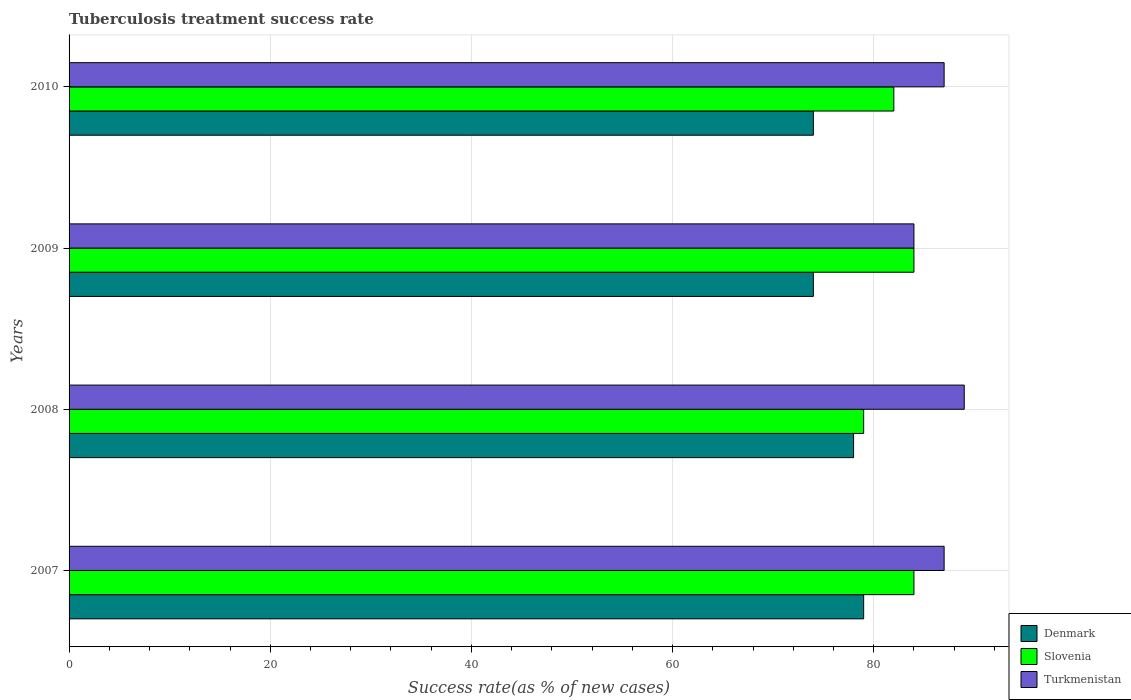Are the number of bars on each tick of the Y-axis equal?
Give a very brief answer. Yes. How many bars are there on the 4th tick from the top?
Offer a very short reply. 3. How many bars are there on the 3rd tick from the bottom?
Offer a terse response. 3. What is the label of the 4th group of bars from the top?
Give a very brief answer. 2007. What is the tuberculosis treatment success rate in Denmark in 2009?
Give a very brief answer. 74. Across all years, what is the maximum tuberculosis treatment success rate in Denmark?
Offer a very short reply. 79. What is the total tuberculosis treatment success rate in Turkmenistan in the graph?
Provide a short and direct response. 347. What is the difference between the tuberculosis treatment success rate in Turkmenistan in 2007 and that in 2010?
Offer a terse response. 0. What is the difference between the tuberculosis treatment success rate in Turkmenistan in 2010 and the tuberculosis treatment success rate in Denmark in 2009?
Provide a short and direct response. 13. What is the average tuberculosis treatment success rate in Denmark per year?
Your response must be concise. 76.25. What is the ratio of the tuberculosis treatment success rate in Slovenia in 2008 to that in 2009?
Give a very brief answer. 0.94. Is the tuberculosis treatment success rate in Slovenia in 2008 less than that in 2010?
Provide a short and direct response. Yes. Is the difference between the tuberculosis treatment success rate in Slovenia in 2007 and 2009 greater than the difference between the tuberculosis treatment success rate in Denmark in 2007 and 2009?
Offer a terse response. No. What is the difference between the highest and the lowest tuberculosis treatment success rate in Denmark?
Keep it short and to the point. 5. In how many years, is the tuberculosis treatment success rate in Denmark greater than the average tuberculosis treatment success rate in Denmark taken over all years?
Your response must be concise. 2. What does the 1st bar from the top in 2008 represents?
Offer a very short reply. Turkmenistan. What does the 3rd bar from the bottom in 2007 represents?
Keep it short and to the point. Turkmenistan. How many bars are there?
Ensure brevity in your answer.  12. What is the difference between two consecutive major ticks on the X-axis?
Offer a terse response. 20. How many legend labels are there?
Keep it short and to the point. 3. What is the title of the graph?
Offer a terse response. Tuberculosis treatment success rate. What is the label or title of the X-axis?
Your response must be concise. Success rate(as % of new cases). What is the label or title of the Y-axis?
Make the answer very short. Years. What is the Success rate(as % of new cases) in Denmark in 2007?
Offer a very short reply. 79. What is the Success rate(as % of new cases) in Turkmenistan in 2007?
Offer a terse response. 87. What is the Success rate(as % of new cases) of Denmark in 2008?
Provide a short and direct response. 78. What is the Success rate(as % of new cases) of Slovenia in 2008?
Ensure brevity in your answer.  79. What is the Success rate(as % of new cases) of Turkmenistan in 2008?
Your answer should be compact. 89. What is the Success rate(as % of new cases) in Slovenia in 2009?
Provide a succinct answer. 84. What is the Success rate(as % of new cases) of Turkmenistan in 2009?
Keep it short and to the point. 84. What is the Success rate(as % of new cases) in Turkmenistan in 2010?
Keep it short and to the point. 87. Across all years, what is the maximum Success rate(as % of new cases) in Denmark?
Make the answer very short. 79. Across all years, what is the maximum Success rate(as % of new cases) of Turkmenistan?
Give a very brief answer. 89. Across all years, what is the minimum Success rate(as % of new cases) of Slovenia?
Give a very brief answer. 79. Across all years, what is the minimum Success rate(as % of new cases) of Turkmenistan?
Your answer should be compact. 84. What is the total Success rate(as % of new cases) in Denmark in the graph?
Offer a very short reply. 305. What is the total Success rate(as % of new cases) of Slovenia in the graph?
Provide a succinct answer. 329. What is the total Success rate(as % of new cases) of Turkmenistan in the graph?
Your answer should be compact. 347. What is the difference between the Success rate(as % of new cases) of Denmark in 2007 and that in 2009?
Your response must be concise. 5. What is the difference between the Success rate(as % of new cases) of Slovenia in 2007 and that in 2009?
Keep it short and to the point. 0. What is the difference between the Success rate(as % of new cases) in Denmark in 2008 and that in 2009?
Ensure brevity in your answer.  4. What is the difference between the Success rate(as % of new cases) of Denmark in 2008 and that in 2010?
Make the answer very short. 4. What is the difference between the Success rate(as % of new cases) of Slovenia in 2008 and that in 2010?
Offer a terse response. -3. What is the difference between the Success rate(as % of new cases) in Denmark in 2007 and the Success rate(as % of new cases) in Turkmenistan in 2008?
Your response must be concise. -10. What is the difference between the Success rate(as % of new cases) in Denmark in 2007 and the Success rate(as % of new cases) in Turkmenistan in 2009?
Offer a terse response. -5. What is the difference between the Success rate(as % of new cases) of Slovenia in 2007 and the Success rate(as % of new cases) of Turkmenistan in 2009?
Offer a terse response. 0. What is the difference between the Success rate(as % of new cases) in Denmark in 2007 and the Success rate(as % of new cases) in Slovenia in 2010?
Your answer should be very brief. -3. What is the difference between the Success rate(as % of new cases) in Slovenia in 2007 and the Success rate(as % of new cases) in Turkmenistan in 2010?
Your answer should be very brief. -3. What is the difference between the Success rate(as % of new cases) in Slovenia in 2008 and the Success rate(as % of new cases) in Turkmenistan in 2009?
Offer a terse response. -5. What is the difference between the Success rate(as % of new cases) in Denmark in 2008 and the Success rate(as % of new cases) in Turkmenistan in 2010?
Ensure brevity in your answer.  -9. What is the difference between the Success rate(as % of new cases) in Slovenia in 2008 and the Success rate(as % of new cases) in Turkmenistan in 2010?
Make the answer very short. -8. What is the difference between the Success rate(as % of new cases) in Denmark in 2009 and the Success rate(as % of new cases) in Slovenia in 2010?
Your answer should be compact. -8. What is the difference between the Success rate(as % of new cases) of Denmark in 2009 and the Success rate(as % of new cases) of Turkmenistan in 2010?
Your response must be concise. -13. What is the difference between the Success rate(as % of new cases) in Slovenia in 2009 and the Success rate(as % of new cases) in Turkmenistan in 2010?
Your answer should be compact. -3. What is the average Success rate(as % of new cases) of Denmark per year?
Ensure brevity in your answer.  76.25. What is the average Success rate(as % of new cases) of Slovenia per year?
Ensure brevity in your answer.  82.25. What is the average Success rate(as % of new cases) in Turkmenistan per year?
Ensure brevity in your answer.  86.75. In the year 2007, what is the difference between the Success rate(as % of new cases) in Denmark and Success rate(as % of new cases) in Turkmenistan?
Offer a terse response. -8. In the year 2008, what is the difference between the Success rate(as % of new cases) in Denmark and Success rate(as % of new cases) in Slovenia?
Give a very brief answer. -1. In the year 2008, what is the difference between the Success rate(as % of new cases) in Denmark and Success rate(as % of new cases) in Turkmenistan?
Make the answer very short. -11. In the year 2009, what is the difference between the Success rate(as % of new cases) of Denmark and Success rate(as % of new cases) of Turkmenistan?
Give a very brief answer. -10. In the year 2009, what is the difference between the Success rate(as % of new cases) in Slovenia and Success rate(as % of new cases) in Turkmenistan?
Your answer should be very brief. 0. In the year 2010, what is the difference between the Success rate(as % of new cases) of Denmark and Success rate(as % of new cases) of Turkmenistan?
Your response must be concise. -13. What is the ratio of the Success rate(as % of new cases) of Denmark in 2007 to that in 2008?
Keep it short and to the point. 1.01. What is the ratio of the Success rate(as % of new cases) in Slovenia in 2007 to that in 2008?
Keep it short and to the point. 1.06. What is the ratio of the Success rate(as % of new cases) of Turkmenistan in 2007 to that in 2008?
Your answer should be compact. 0.98. What is the ratio of the Success rate(as % of new cases) of Denmark in 2007 to that in 2009?
Offer a terse response. 1.07. What is the ratio of the Success rate(as % of new cases) of Turkmenistan in 2007 to that in 2009?
Provide a succinct answer. 1.04. What is the ratio of the Success rate(as % of new cases) of Denmark in 2007 to that in 2010?
Your answer should be compact. 1.07. What is the ratio of the Success rate(as % of new cases) of Slovenia in 2007 to that in 2010?
Make the answer very short. 1.02. What is the ratio of the Success rate(as % of new cases) of Turkmenistan in 2007 to that in 2010?
Provide a short and direct response. 1. What is the ratio of the Success rate(as % of new cases) in Denmark in 2008 to that in 2009?
Give a very brief answer. 1.05. What is the ratio of the Success rate(as % of new cases) in Slovenia in 2008 to that in 2009?
Offer a very short reply. 0.94. What is the ratio of the Success rate(as % of new cases) in Turkmenistan in 2008 to that in 2009?
Give a very brief answer. 1.06. What is the ratio of the Success rate(as % of new cases) in Denmark in 2008 to that in 2010?
Make the answer very short. 1.05. What is the ratio of the Success rate(as % of new cases) of Slovenia in 2008 to that in 2010?
Make the answer very short. 0.96. What is the ratio of the Success rate(as % of new cases) in Turkmenistan in 2008 to that in 2010?
Keep it short and to the point. 1.02. What is the ratio of the Success rate(as % of new cases) in Slovenia in 2009 to that in 2010?
Your answer should be compact. 1.02. What is the ratio of the Success rate(as % of new cases) of Turkmenistan in 2009 to that in 2010?
Your answer should be very brief. 0.97. What is the difference between the highest and the second highest Success rate(as % of new cases) in Slovenia?
Provide a succinct answer. 0. What is the difference between the highest and the second highest Success rate(as % of new cases) of Turkmenistan?
Make the answer very short. 2. What is the difference between the highest and the lowest Success rate(as % of new cases) in Denmark?
Make the answer very short. 5. 